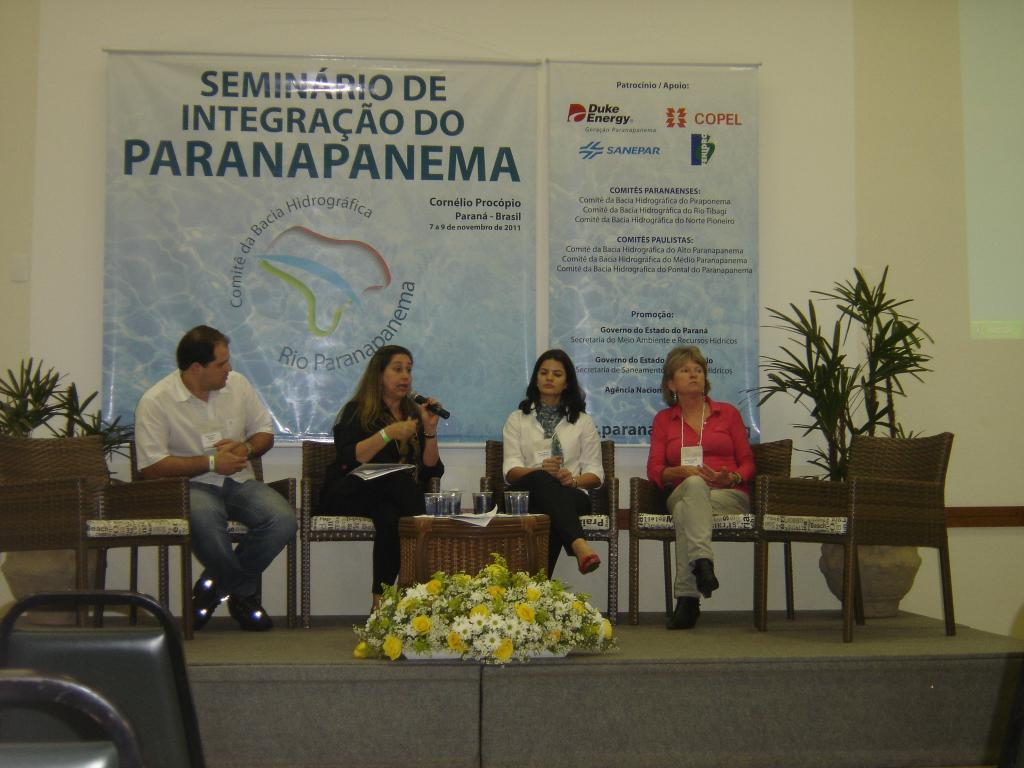Who or what can be seen in the image? There are people in the image. What are the people doing in the image? The people are sitting on chairs. What is in front of the chairs? There is a table in front of the chairs. What objects are on the table? Glasses are present on the table. What type of farm animals can be seen in the image? There are no farm animals present in the image. How many rings are visible on the people's fingers in the image? There is no information about rings on the people's fingers in the image. 